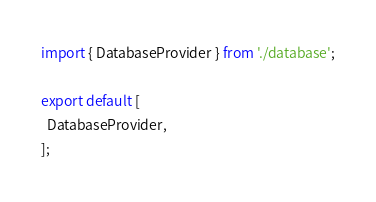Convert code to text. <code><loc_0><loc_0><loc_500><loc_500><_TypeScript_>import { DatabaseProvider } from './database';

export default [
  DatabaseProvider,
];
</code> 